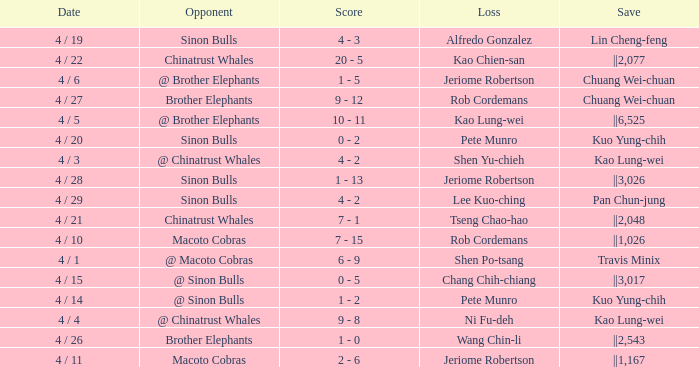Who earned the save in the game against the Sinon Bulls when Jeriome Robertson took the loss? ||3,026. 